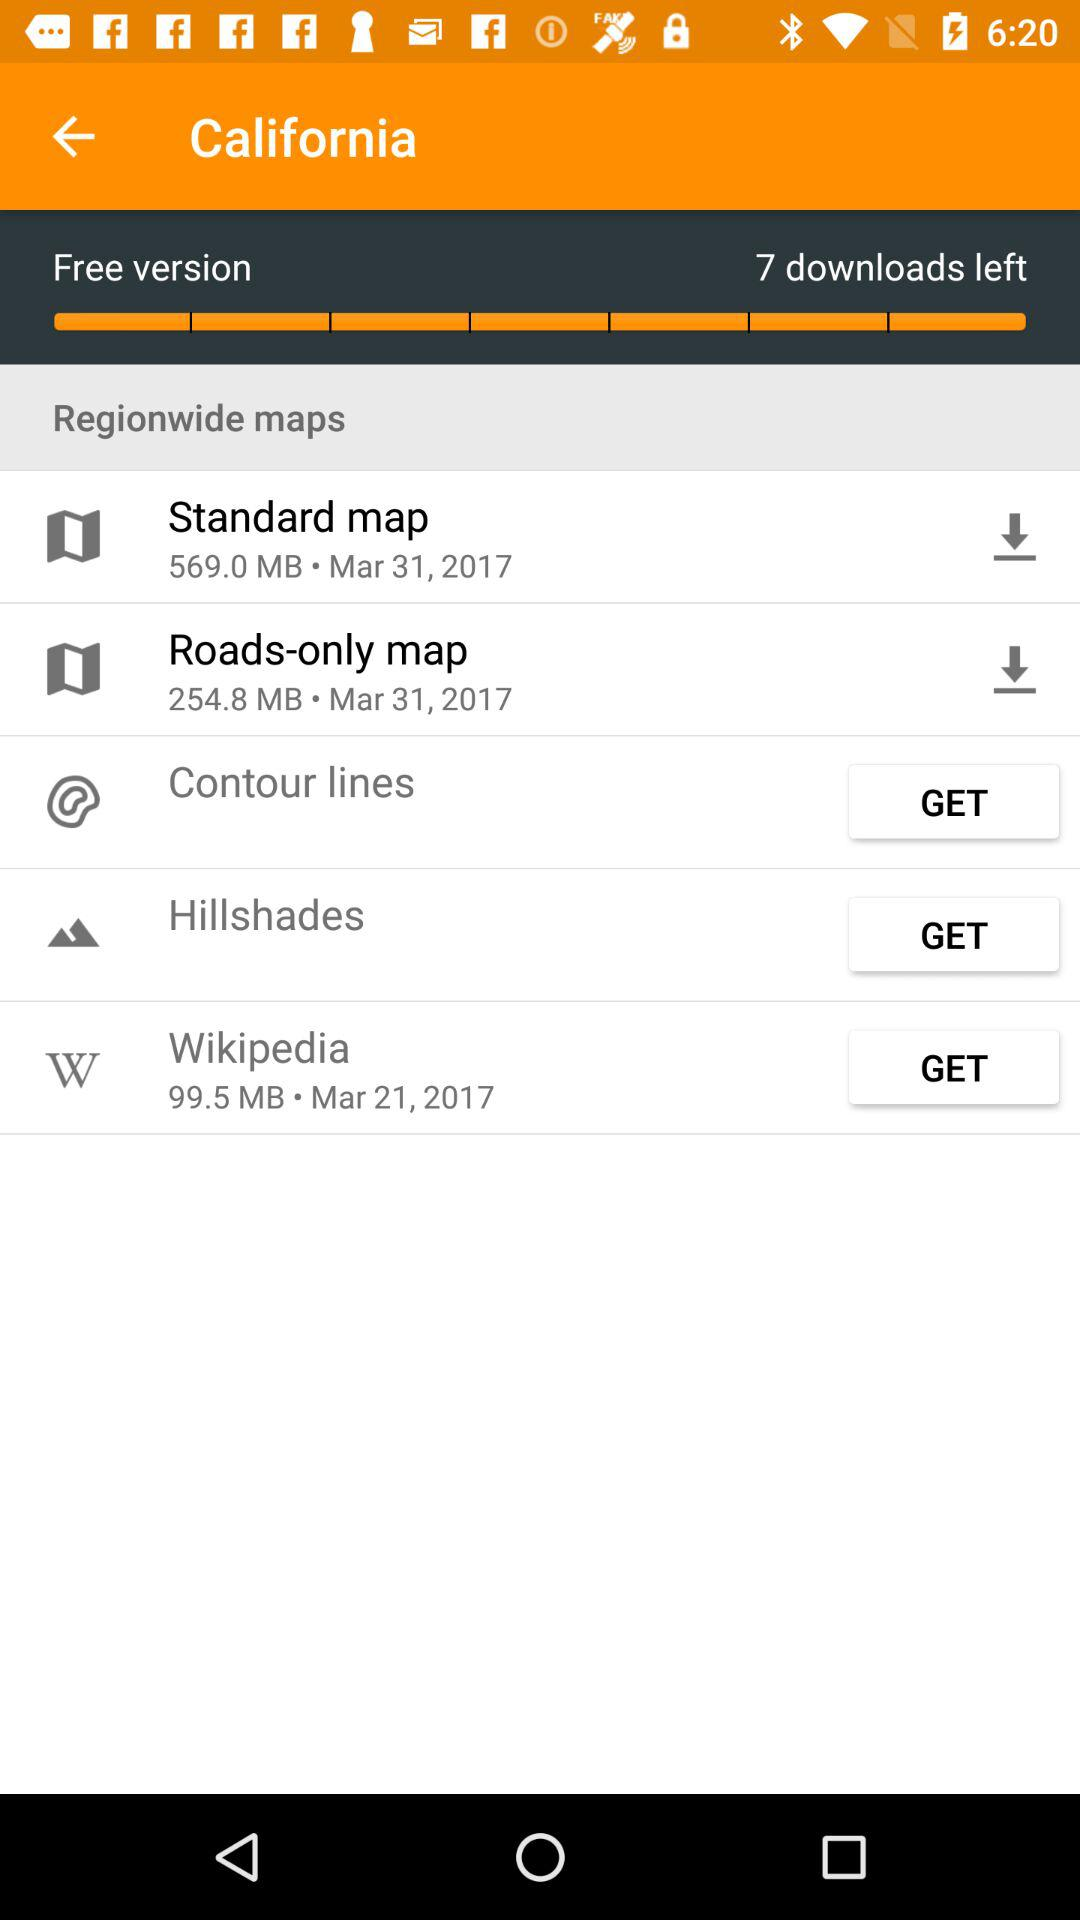How many downloads are left? There are 7 downloads left. 